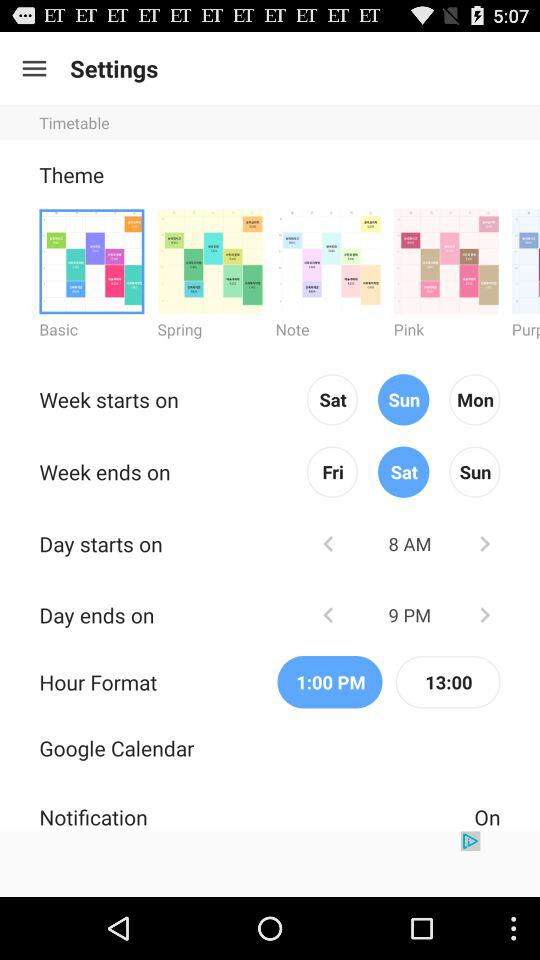When does the day end? The day ends at 9 PM. 